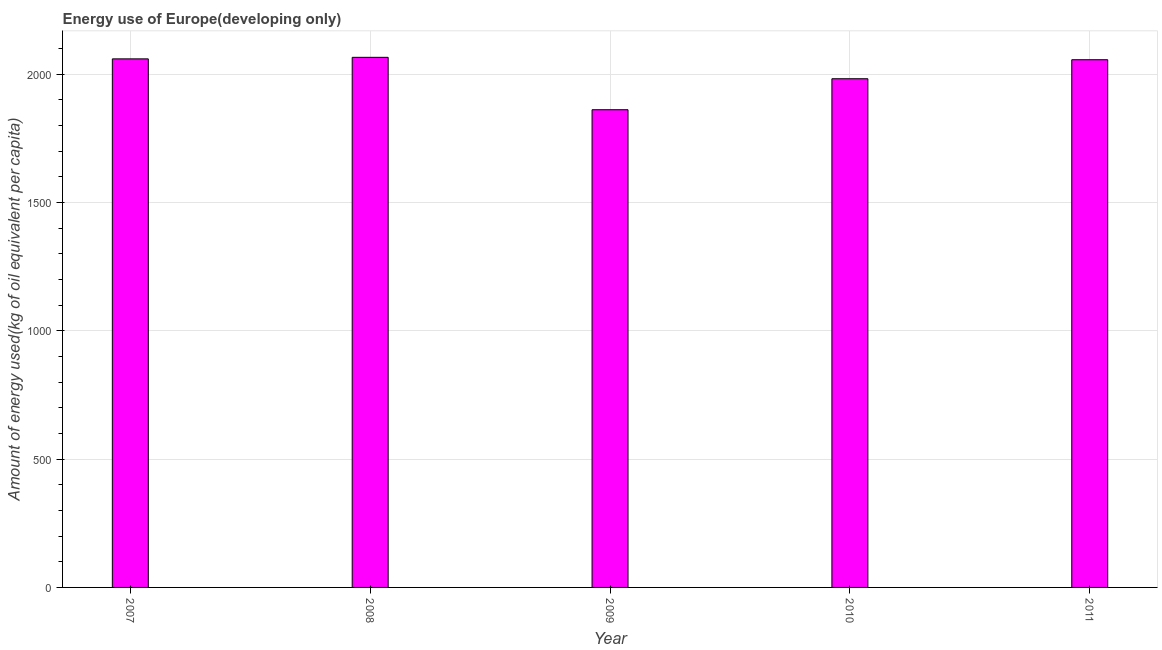Does the graph contain grids?
Your answer should be very brief. Yes. What is the title of the graph?
Your answer should be very brief. Energy use of Europe(developing only). What is the label or title of the Y-axis?
Offer a terse response. Amount of energy used(kg of oil equivalent per capita). What is the amount of energy used in 2007?
Your response must be concise. 2060.29. Across all years, what is the maximum amount of energy used?
Provide a succinct answer. 2066.27. Across all years, what is the minimum amount of energy used?
Your answer should be compact. 1862.01. In which year was the amount of energy used maximum?
Give a very brief answer. 2008. What is the sum of the amount of energy used?
Offer a terse response. 1.00e+04. What is the difference between the amount of energy used in 2008 and 2011?
Keep it short and to the point. 9.32. What is the average amount of energy used per year?
Give a very brief answer. 2005.67. What is the median amount of energy used?
Provide a short and direct response. 2056.94. Do a majority of the years between 2008 and 2010 (inclusive) have amount of energy used greater than 500 kg?
Give a very brief answer. Yes. What is the ratio of the amount of energy used in 2009 to that in 2011?
Give a very brief answer. 0.91. Is the amount of energy used in 2008 less than that in 2009?
Offer a very short reply. No. Is the difference between the amount of energy used in 2008 and 2011 greater than the difference between any two years?
Offer a terse response. No. What is the difference between the highest and the second highest amount of energy used?
Offer a very short reply. 5.98. Is the sum of the amount of energy used in 2010 and 2011 greater than the maximum amount of energy used across all years?
Your answer should be compact. Yes. What is the difference between the highest and the lowest amount of energy used?
Your response must be concise. 204.26. What is the difference between two consecutive major ticks on the Y-axis?
Provide a succinct answer. 500. Are the values on the major ticks of Y-axis written in scientific E-notation?
Keep it short and to the point. No. What is the Amount of energy used(kg of oil equivalent per capita) in 2007?
Make the answer very short. 2060.29. What is the Amount of energy used(kg of oil equivalent per capita) of 2008?
Give a very brief answer. 2066.27. What is the Amount of energy used(kg of oil equivalent per capita) of 2009?
Your response must be concise. 1862.01. What is the Amount of energy used(kg of oil equivalent per capita) in 2010?
Your response must be concise. 1982.83. What is the Amount of energy used(kg of oil equivalent per capita) in 2011?
Provide a succinct answer. 2056.94. What is the difference between the Amount of energy used(kg of oil equivalent per capita) in 2007 and 2008?
Your answer should be compact. -5.98. What is the difference between the Amount of energy used(kg of oil equivalent per capita) in 2007 and 2009?
Ensure brevity in your answer.  198.28. What is the difference between the Amount of energy used(kg of oil equivalent per capita) in 2007 and 2010?
Offer a terse response. 77.45. What is the difference between the Amount of energy used(kg of oil equivalent per capita) in 2007 and 2011?
Provide a succinct answer. 3.35. What is the difference between the Amount of energy used(kg of oil equivalent per capita) in 2008 and 2009?
Your answer should be compact. 204.26. What is the difference between the Amount of energy used(kg of oil equivalent per capita) in 2008 and 2010?
Ensure brevity in your answer.  83.43. What is the difference between the Amount of energy used(kg of oil equivalent per capita) in 2008 and 2011?
Provide a succinct answer. 9.32. What is the difference between the Amount of energy used(kg of oil equivalent per capita) in 2009 and 2010?
Your answer should be very brief. -120.82. What is the difference between the Amount of energy used(kg of oil equivalent per capita) in 2009 and 2011?
Ensure brevity in your answer.  -194.93. What is the difference between the Amount of energy used(kg of oil equivalent per capita) in 2010 and 2011?
Ensure brevity in your answer.  -74.11. What is the ratio of the Amount of energy used(kg of oil equivalent per capita) in 2007 to that in 2008?
Offer a terse response. 1. What is the ratio of the Amount of energy used(kg of oil equivalent per capita) in 2007 to that in 2009?
Provide a succinct answer. 1.11. What is the ratio of the Amount of energy used(kg of oil equivalent per capita) in 2007 to that in 2010?
Keep it short and to the point. 1.04. What is the ratio of the Amount of energy used(kg of oil equivalent per capita) in 2008 to that in 2009?
Keep it short and to the point. 1.11. What is the ratio of the Amount of energy used(kg of oil equivalent per capita) in 2008 to that in 2010?
Provide a short and direct response. 1.04. What is the ratio of the Amount of energy used(kg of oil equivalent per capita) in 2008 to that in 2011?
Your answer should be very brief. 1. What is the ratio of the Amount of energy used(kg of oil equivalent per capita) in 2009 to that in 2010?
Offer a very short reply. 0.94. What is the ratio of the Amount of energy used(kg of oil equivalent per capita) in 2009 to that in 2011?
Your response must be concise. 0.91. 